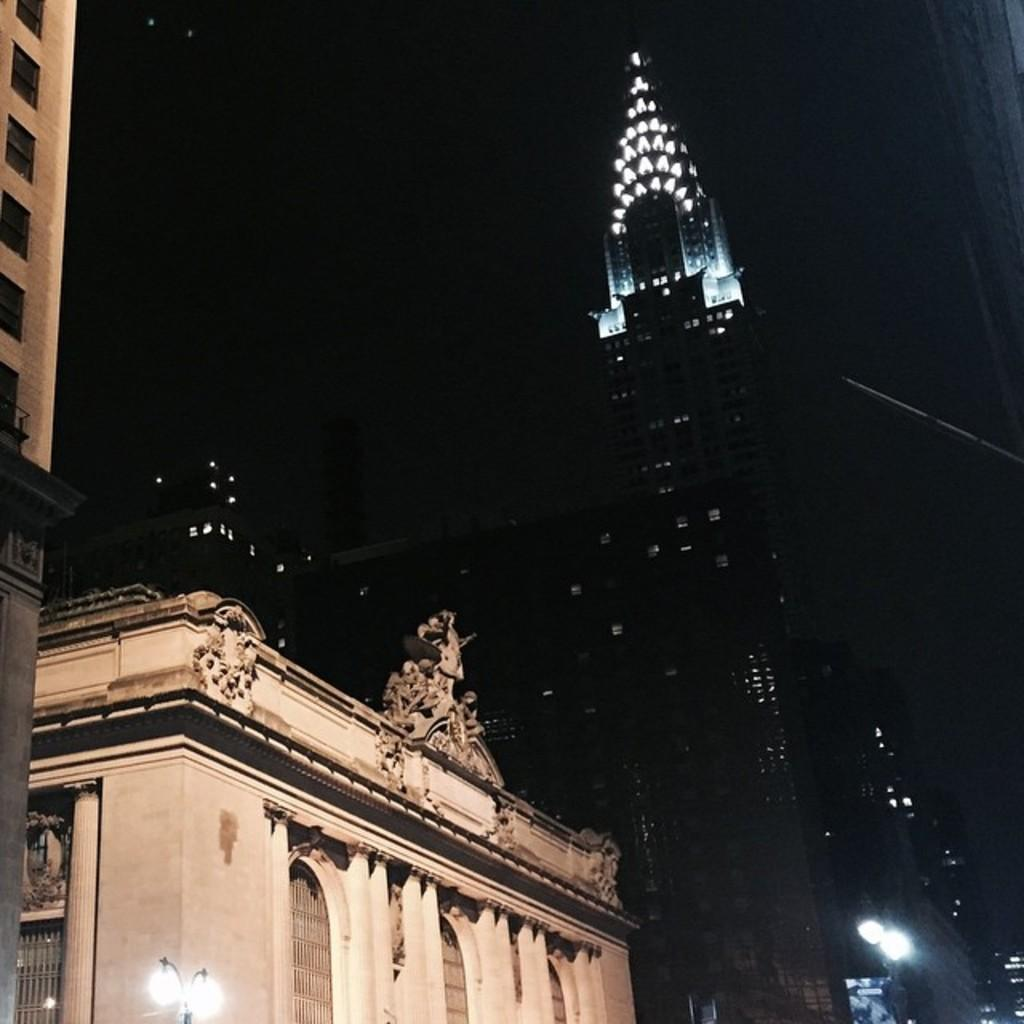What type of structures are present in the image? There are buildings and skyscrapers in the image. What can be seen illuminating the scene in the image? There are lights and street lights in the image. What type of substance is being poured from the bucket onto the sofa in the image? There is no bucket or sofa present in the image. 